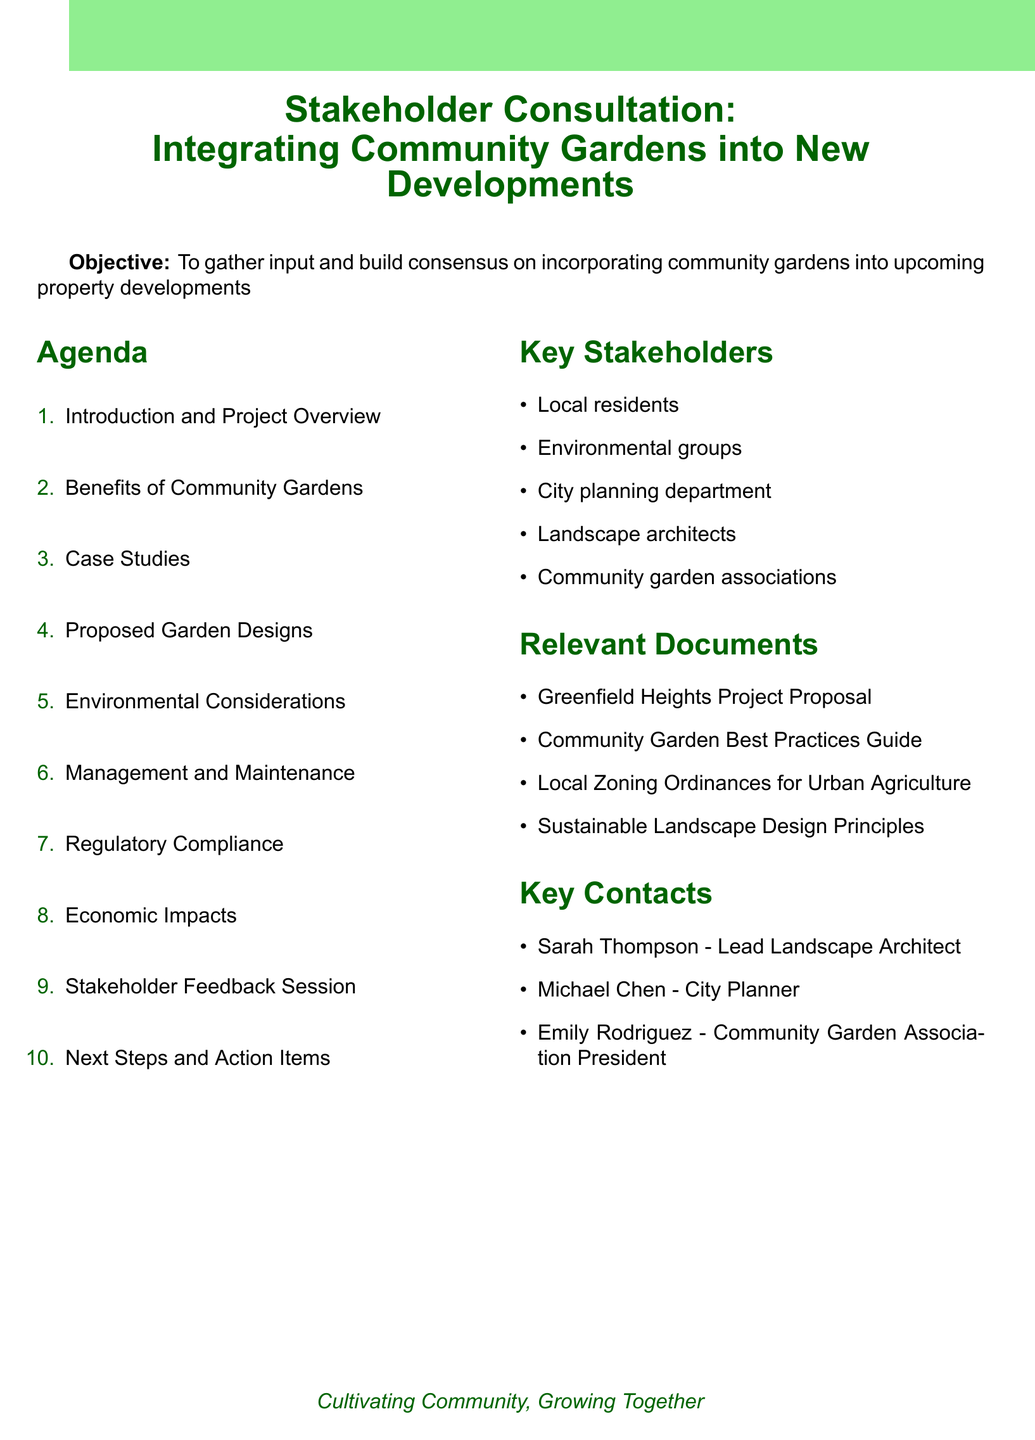What is the title of the meeting? The title is presented in the header of the document.
Answer: Stakeholder Consultation: Integrating Community Gardens into New Developments What is the objective of the meeting? The objective is stated right after the title in the document.
Answer: To gather input and build consensus on incorporating community gardens into upcoming property developments Who are the key stakeholders listed? The key stakeholders are outlined in a section of the document.
Answer: Local residents, Environmental groups, City planning department, Landscape architects, Community garden associations What is one benefit of community gardens mentioned? The benefits are detailed in a specific section of the agenda.
Answer: Enhanced property values Name one of the proposed garden designs. The proposed garden designs are listed in the agenda.
Answer: Rooftop gardens What is a key environmental consideration mentioned? Environmental considerations are detailed in a section of the document.
Answer: Water conservation techniques What type of session is planned for stakeholder feedback? The methods for stakeholder feedback are outlined in the document.
Answer: Open forum discussion How many case studies are presented? They are listed in the case studies section of the agenda.
Answer: Three What is one next step after the stakeholder consultation? The next steps are listed at the end of the agenda.
Answer: Compile and analyze stakeholder input 